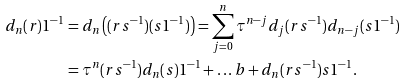Convert formula to latex. <formula><loc_0><loc_0><loc_500><loc_500>d _ { n } ( r ) 1 ^ { - 1 } & = d _ { n } \left ( ( r s ^ { - 1 } ) ( s 1 ^ { - 1 } ) \right ) = \sum _ { j = 0 } ^ { n } \tau ^ { n - j } d _ { j } ( r s ^ { - 1 } ) d _ { n - j } ( s 1 ^ { - 1 } ) \\ & = \tau ^ { n } ( r s ^ { - 1 } ) d _ { n } ( s ) 1 ^ { - 1 } + \dots b + d _ { n } ( r s ^ { - 1 } ) s 1 ^ { - 1 } .</formula> 